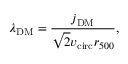Convert formula to latex. <formula><loc_0><loc_0><loc_500><loc_500>\lambda _ { D M } = \frac { j _ { D M } } { \sqrt { 2 } v _ { c i r c } r _ { 5 0 0 } } ,</formula> 